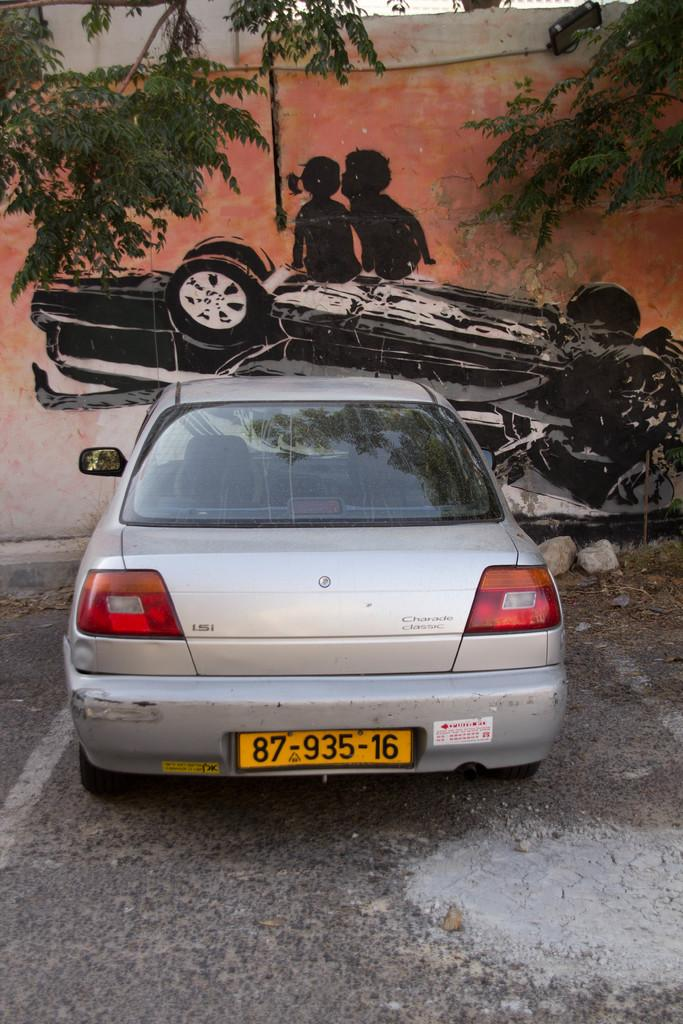<image>
Write a terse but informative summary of the picture. A Charade Classic car with a tag reading 87-935-16. 